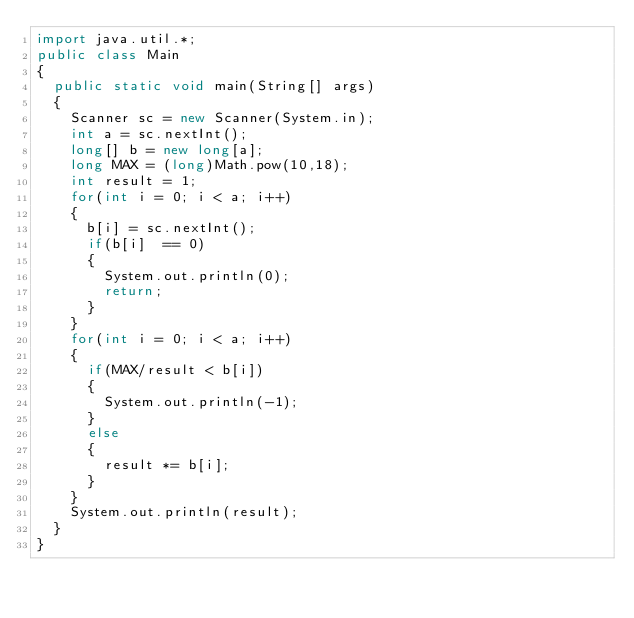<code> <loc_0><loc_0><loc_500><loc_500><_Java_>import java.util.*;
public class Main
{
  public static void main(String[] args)
  {
    Scanner sc = new Scanner(System.in);
    int a = sc.nextInt();
    long[] b = new long[a];
    long MAX = (long)Math.pow(10,18);
    int result = 1;
    for(int i = 0; i < a; i++)
    {
      b[i] = sc.nextInt();
      if(b[i]  == 0)
      {
        System.out.println(0);
      	return;
      }
    }
    for(int i = 0; i < a; i++)
    {
      if(MAX/result < b[i])
      {
        System.out.println(-1);
      }
      else
      {
        result *= b[i];
      }
    }
    System.out.println(result);
  }
}
</code> 